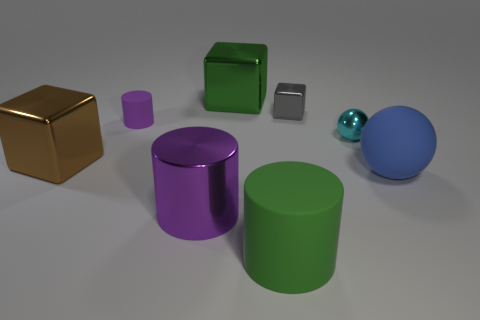Are there any gray cubes?
Make the answer very short. Yes. What color is the object that is to the left of the big purple cylinder and to the right of the brown shiny cube?
Make the answer very short. Purple. There is a purple thing that is behind the cyan ball; is its size the same as the green object that is in front of the shiny ball?
Ensure brevity in your answer.  No. What number of other objects are there of the same size as the green matte cylinder?
Make the answer very short. 4. What number of tiny purple rubber things are in front of the big metal cube on the right side of the brown object?
Offer a terse response. 1. Is the number of tiny purple objects that are in front of the cyan metallic object less than the number of metallic cubes?
Your answer should be compact. Yes. What is the shape of the purple thing that is behind the large object that is left of the large cylinder behind the green matte cylinder?
Your answer should be compact. Cylinder. Do the tiny gray thing and the green matte thing have the same shape?
Offer a terse response. No. What number of other things are there of the same shape as the large green shiny object?
Offer a terse response. 2. What color is the cylinder that is the same size as the gray cube?
Provide a succinct answer. Purple. 